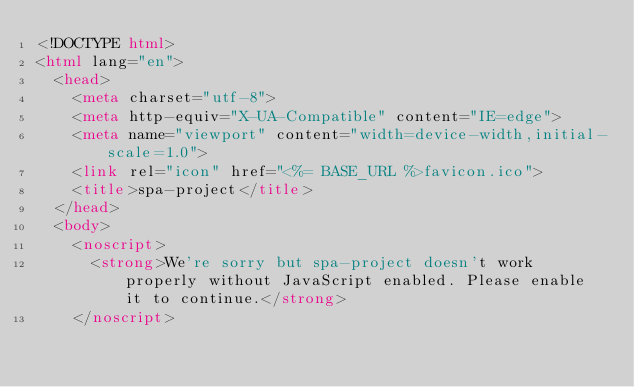<code> <loc_0><loc_0><loc_500><loc_500><_HTML_><!DOCTYPE html>
<html lang="en">
  <head>
    <meta charset="utf-8">
    <meta http-equiv="X-UA-Compatible" content="IE=edge">
    <meta name="viewport" content="width=device-width,initial-scale=1.0">
    <link rel="icon" href="<%= BASE_URL %>favicon.ico">
    <title>spa-project</title>
  </head>
  <body>
    <noscript>
      <strong>We're sorry but spa-project doesn't work properly without JavaScript enabled. Please enable it to continue.</strong>
    </noscript></code> 